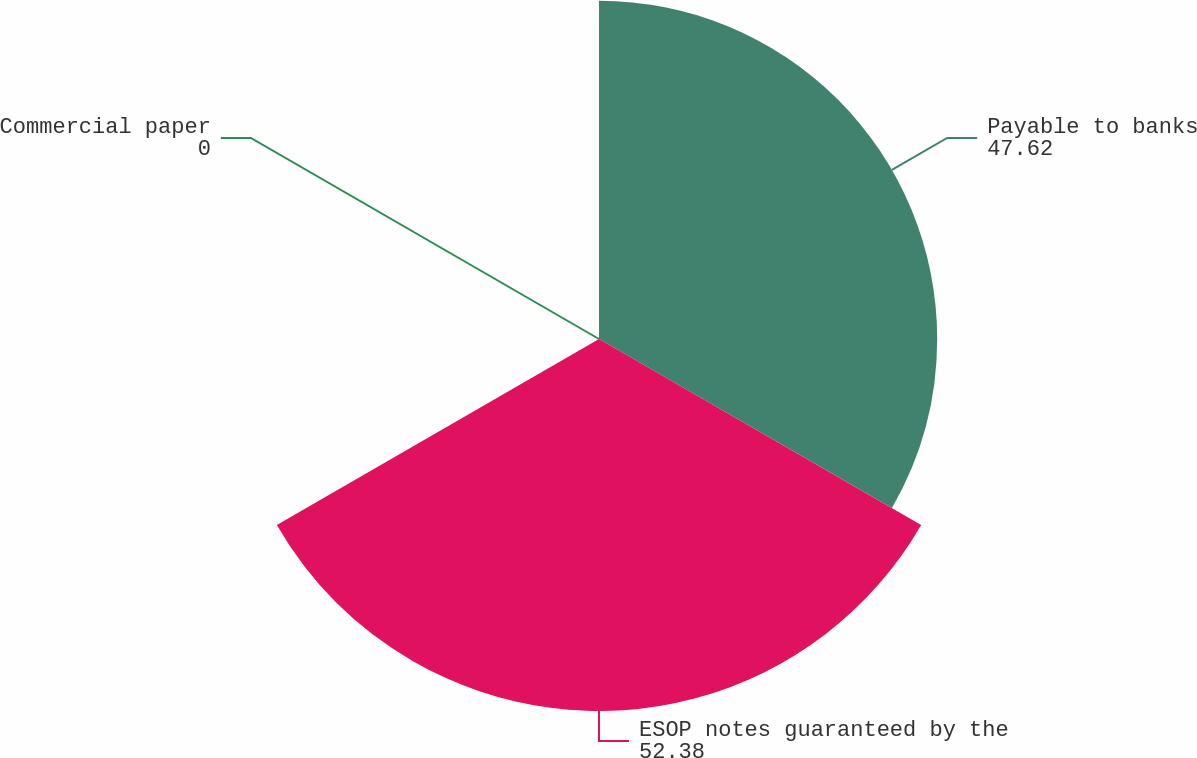Convert chart to OTSL. <chart><loc_0><loc_0><loc_500><loc_500><pie_chart><fcel>Payable to banks<fcel>ESOP notes guaranteed by the<fcel>Commercial paper<nl><fcel>47.62%<fcel>52.38%<fcel>0.0%<nl></chart> 